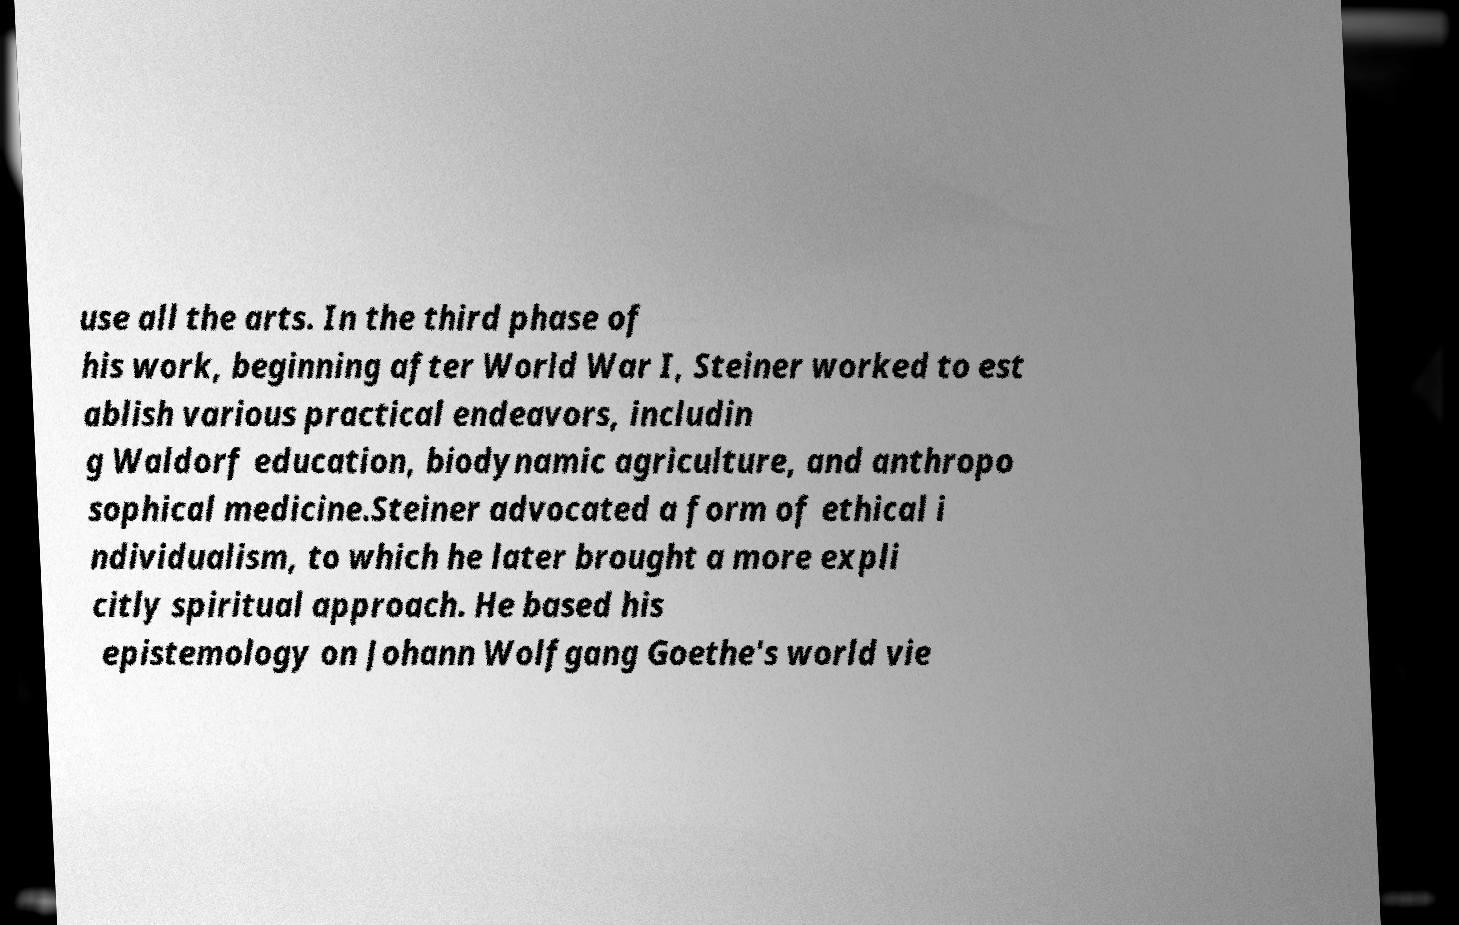Please identify and transcribe the text found in this image. use all the arts. In the third phase of his work, beginning after World War I, Steiner worked to est ablish various practical endeavors, includin g Waldorf education, biodynamic agriculture, and anthropo sophical medicine.Steiner advocated a form of ethical i ndividualism, to which he later brought a more expli citly spiritual approach. He based his epistemology on Johann Wolfgang Goethe's world vie 